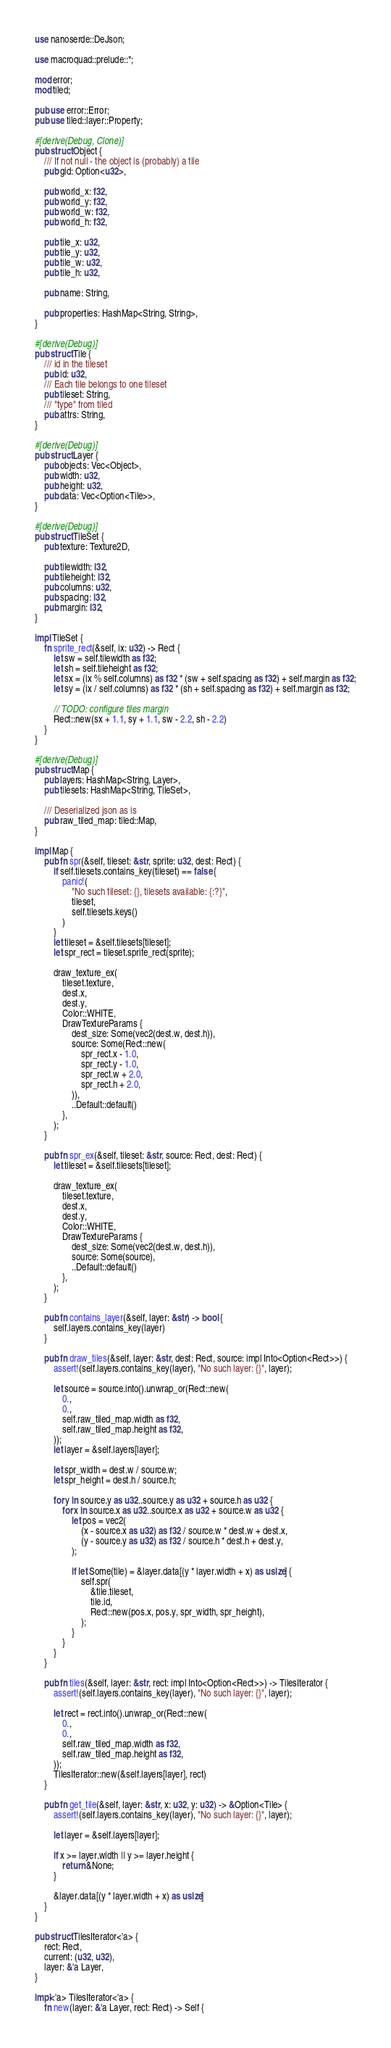<code> <loc_0><loc_0><loc_500><loc_500><_Rust_>use nanoserde::DeJson;

use macroquad::prelude::*;

mod error;
mod tiled;

pub use error::Error;
pub use tiled::layer::Property;

#[derive(Debug, Clone)]
pub struct Object {
    /// If not null - the object is (probably) a tile
    pub gid: Option<u32>,

    pub world_x: f32,
    pub world_y: f32,
    pub world_w: f32,
    pub world_h: f32,

    pub tile_x: u32,
    pub tile_y: u32,
    pub tile_w: u32,
    pub tile_h: u32,

    pub name: String,

    pub properties: HashMap<String, String>,
}

#[derive(Debug)]
pub struct Tile {
    /// id in the tileset
    pub id: u32,
    /// Each tile belongs to one tileset
    pub tileset: String,
    /// "type" from tiled
    pub attrs: String,
}

#[derive(Debug)]
pub struct Layer {
    pub objects: Vec<Object>,
    pub width: u32,
    pub height: u32,
    pub data: Vec<Option<Tile>>,
}

#[derive(Debug)]
pub struct TileSet {
    pub texture: Texture2D,

    pub tilewidth: i32,
    pub tileheight: i32,
    pub columns: u32,
    pub spacing: i32,
    pub margin: i32,
}

impl TileSet {
    fn sprite_rect(&self, ix: u32) -> Rect {
        let sw = self.tilewidth as f32;
        let sh = self.tileheight as f32;
        let sx = (ix % self.columns) as f32 * (sw + self.spacing as f32) + self.margin as f32;
        let sy = (ix / self.columns) as f32 * (sh + self.spacing as f32) + self.margin as f32;

        // TODO: configure tiles margin
        Rect::new(sx + 1.1, sy + 1.1, sw - 2.2, sh - 2.2)
    }
}

#[derive(Debug)]
pub struct Map {
    pub layers: HashMap<String, Layer>,
    pub tilesets: HashMap<String, TileSet>,

    /// Deserialized json as is
    pub raw_tiled_map: tiled::Map,
}

impl Map {
    pub fn spr(&self, tileset: &str, sprite: u32, dest: Rect) {
        if self.tilesets.contains_key(tileset) == false {
            panic!(
                "No such tileset: {}, tilesets available: {:?}",
                tileset,
                self.tilesets.keys()
            )
        }
        let tileset = &self.tilesets[tileset];
        let spr_rect = tileset.sprite_rect(sprite);

        draw_texture_ex(
            tileset.texture,
            dest.x,
            dest.y,
            Color::WHITE,
            DrawTextureParams {
                dest_size: Some(vec2(dest.w, dest.h)),
                source: Some(Rect::new(
                    spr_rect.x - 1.0,
                    spr_rect.y - 1.0,
                    spr_rect.w + 2.0,
                    spr_rect.h + 2.0,
                )),
                ..Default::default()
            },
        );
    }

    pub fn spr_ex(&self, tileset: &str, source: Rect, dest: Rect) {
        let tileset = &self.tilesets[tileset];

        draw_texture_ex(
            tileset.texture,
            dest.x,
            dest.y,
            Color::WHITE,
            DrawTextureParams {
                dest_size: Some(vec2(dest.w, dest.h)),
                source: Some(source),
                ..Default::default()
            },
        );
    }

    pub fn contains_layer(&self, layer: &str) -> bool {
        self.layers.contains_key(layer)
    }

    pub fn draw_tiles(&self, layer: &str, dest: Rect, source: impl Into<Option<Rect>>) {
        assert!(self.layers.contains_key(layer), "No such layer: {}", layer);

        let source = source.into().unwrap_or(Rect::new(
            0.,
            0.,
            self.raw_tiled_map.width as f32,
            self.raw_tiled_map.height as f32,
        ));
        let layer = &self.layers[layer];

        let spr_width = dest.w / source.w;
        let spr_height = dest.h / source.h;

        for y in source.y as u32..source.y as u32 + source.h as u32 {
            for x in source.x as u32..source.x as u32 + source.w as u32 {
                let pos = vec2(
                    (x - source.x as u32) as f32 / source.w * dest.w + dest.x,
                    (y - source.y as u32) as f32 / source.h * dest.h + dest.y,
                );

                if let Some(tile) = &layer.data[(y * layer.width + x) as usize] {
                    self.spr(
                        &tile.tileset,
                        tile.id,
                        Rect::new(pos.x, pos.y, spr_width, spr_height),
                    );
                }
            }
        }
    }

    pub fn tiles(&self, layer: &str, rect: impl Into<Option<Rect>>) -> TilesIterator {
        assert!(self.layers.contains_key(layer), "No such layer: {}", layer);

        let rect = rect.into().unwrap_or(Rect::new(
            0.,
            0.,
            self.raw_tiled_map.width as f32,
            self.raw_tiled_map.height as f32,
        ));
        TilesIterator::new(&self.layers[layer], rect)
    }

    pub fn get_tile(&self, layer: &str, x: u32, y: u32) -> &Option<Tile> {
        assert!(self.layers.contains_key(layer), "No such layer: {}", layer);

        let layer = &self.layers[layer];

        if x >= layer.width || y >= layer.height {
            return &None;
        }

        &layer.data[(y * layer.width + x) as usize]
    }
}

pub struct TilesIterator<'a> {
    rect: Rect,
    current: (u32, u32),
    layer: &'a Layer,
}

impl<'a> TilesIterator<'a> {
    fn new(layer: &'a Layer, rect: Rect) -> Self {</code> 